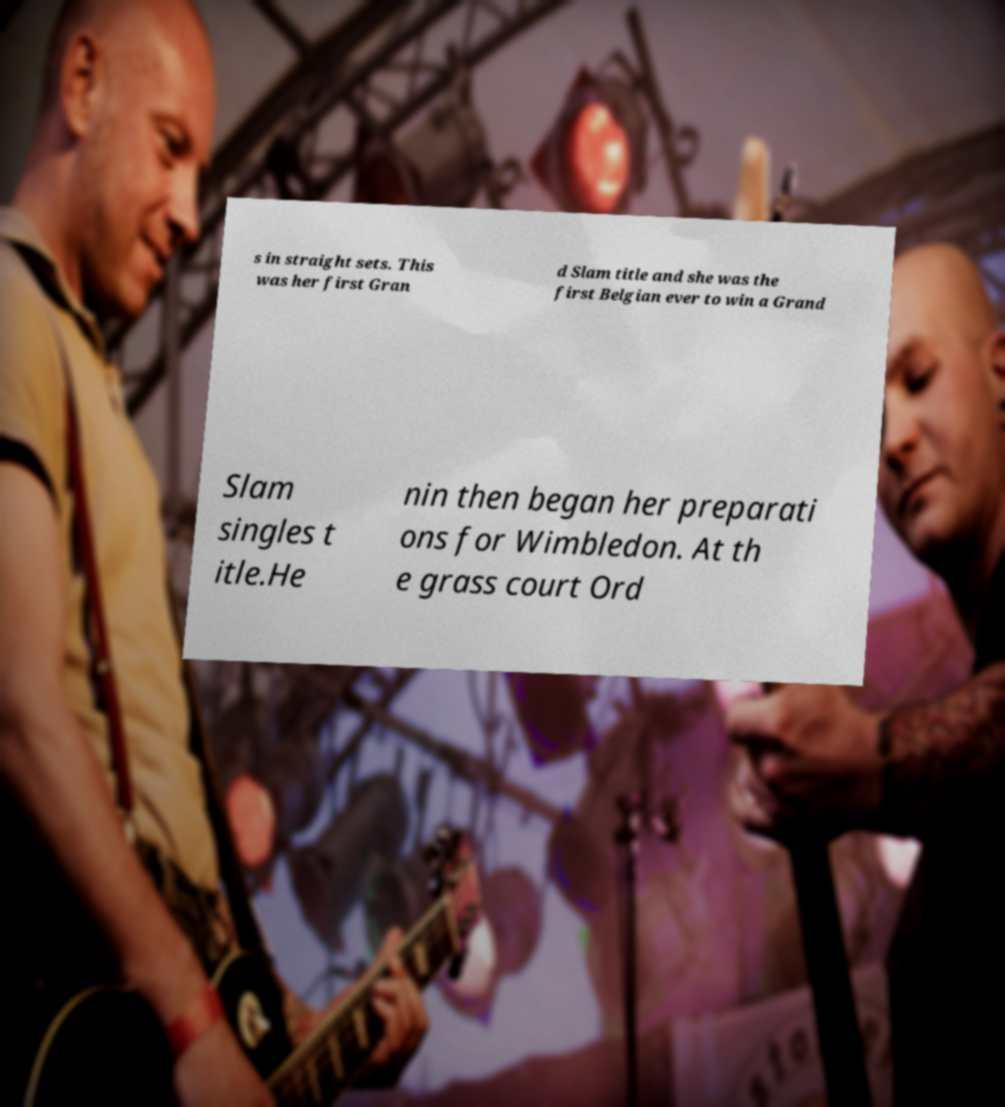Please identify and transcribe the text found in this image. s in straight sets. This was her first Gran d Slam title and she was the first Belgian ever to win a Grand Slam singles t itle.He nin then began her preparati ons for Wimbledon. At th e grass court Ord 